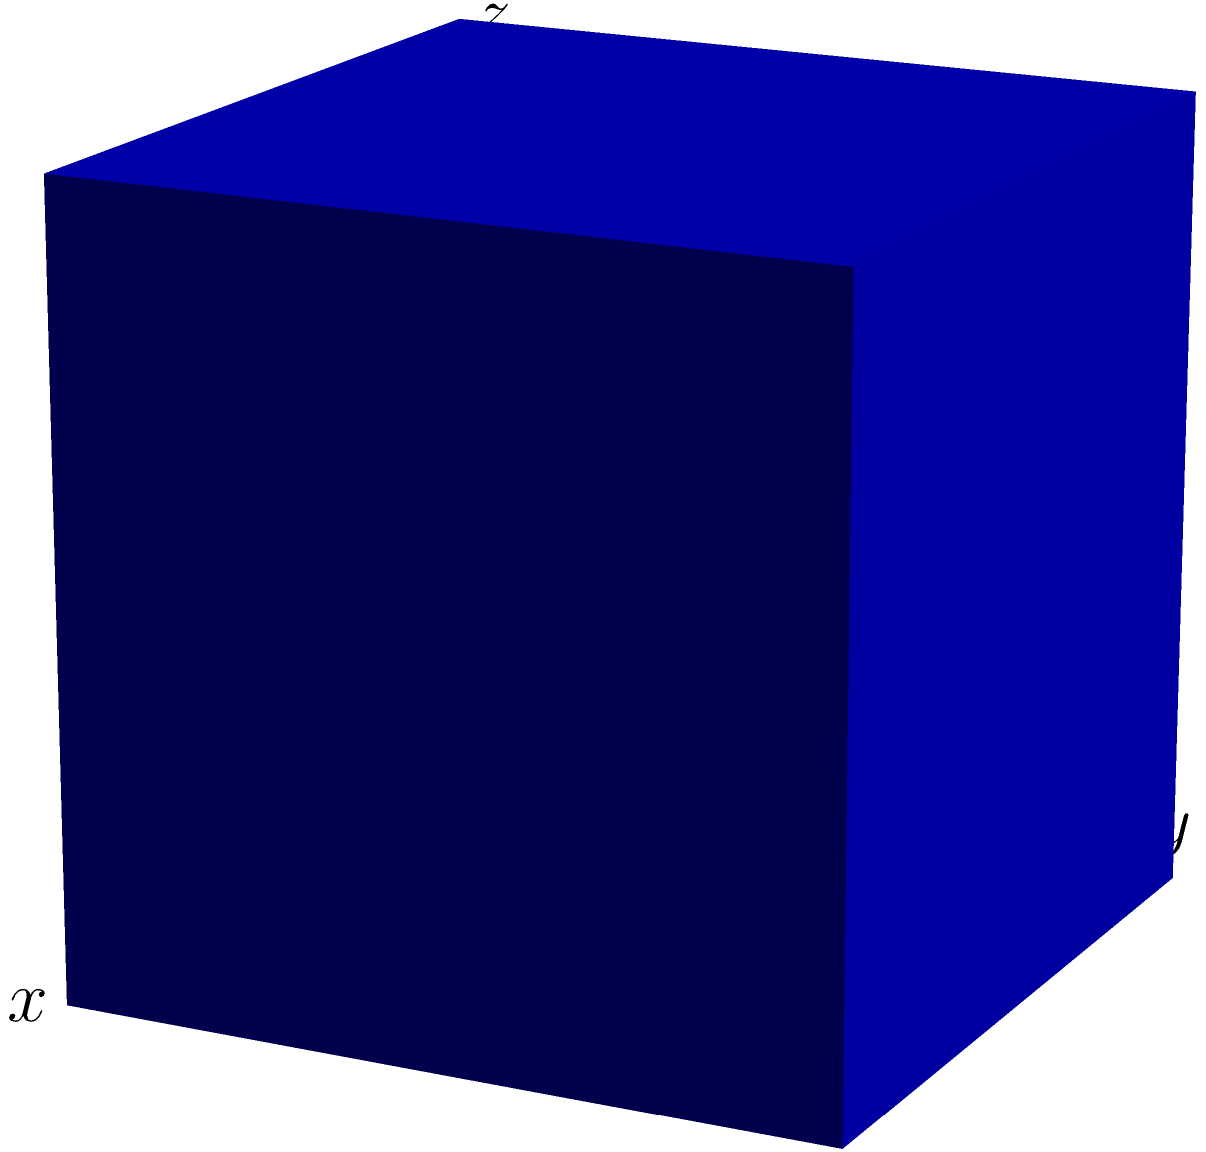In traditional Tianjin architecture, cube-shaped building blocks were often used. If one such block has an edge length of $a$ meters, what is the total surface area of the block in square meters? To find the total surface area of a cube-shaped building block, we need to follow these steps:

1. Identify the shape: The block is a cube, which has 6 identical square faces.

2. Calculate the area of one face:
   - Each face is a square with side length $a$
   - Area of one face = $a^2$ square meters

3. Calculate the total surface area:
   - Total surface area = Area of one face × Number of faces
   - Total surface area = $a^2 \times 6$
   - Total surface area = $6a^2$ square meters

Therefore, the total surface area of the cube-shaped building block used in traditional Tianjin architecture is $6a^2$ square meters, where $a$ is the length of one edge in meters.
Answer: $6a^2$ square meters 